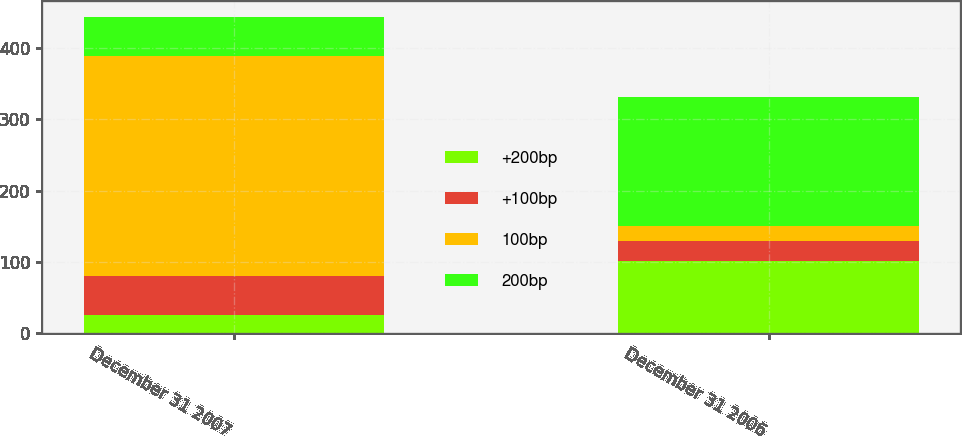Convert chart to OTSL. <chart><loc_0><loc_0><loc_500><loc_500><stacked_bar_chart><ecel><fcel>December 31 2007<fcel>December 31 2006<nl><fcel>+200bp<fcel>26<fcel>101<nl><fcel>+100bp<fcel>55<fcel>28<nl><fcel>100bp<fcel>308<fcel>21<nl><fcel>200bp<fcel>55<fcel>182<nl></chart> 